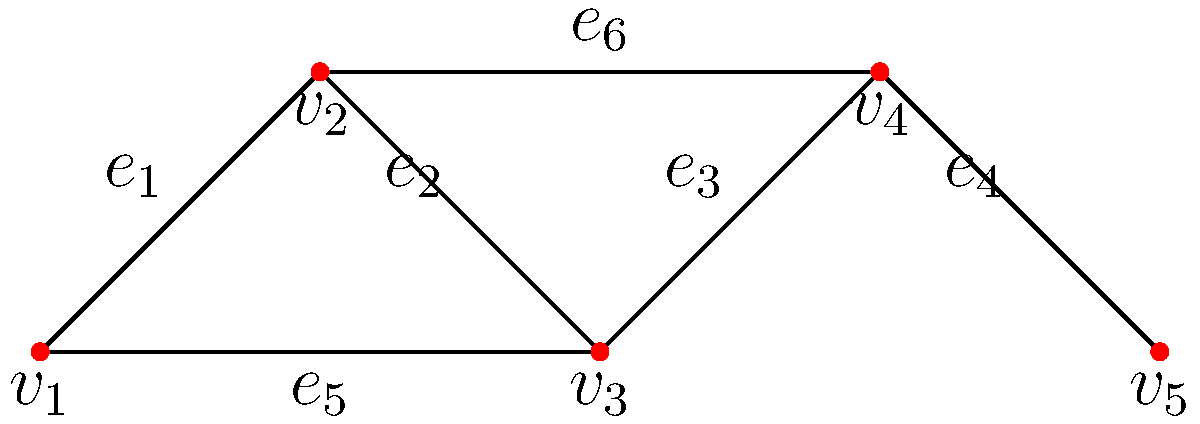As a city council member, you're reviewing a proposal to improve the connectivity of your city's road network. The current network is represented by the graph above, where vertices represent intersections and edges represent roads. What is the minimum number of additional roads (edges) that need to be constructed to make this graph 2-edge-connected, ensuring that the removal of any single road won't disconnect the network? To solve this problem, we need to understand the concept of 2-edge-connectivity and analyze the given graph:

1. A graph is 2-edge-connected if it remains connected after removing any single edge.

2. Examine the current graph:
   - It has 5 vertices ($v_1$ to $v_5$) and 6 edges ($e_1$ to $e_6$).
   - The graph is connected, but not 2-edge-connected.

3. Identify critical edges:
   - $e_4$ is a critical edge. If removed, it disconnects $v_5$ from the rest of the graph.
   - $e_5$ and $e_6$ are not critical, as their removal doesn't disconnect the graph.

4. To make the graph 2-edge-connected:
   - We need to add one edge to create an alternative path to $v_5$.
   - The most efficient option is to add an edge between $v_5$ and any other vertex except $v_4$.

5. Possible solutions:
   - Add an edge between $v_5$ and $v_1$, $v_2$, or $v_3$.
   - Any of these additions will make the graph 2-edge-connected.

6. Minimum number of edges to add:
   - Only one edge needs to be added to achieve 2-edge-connectivity.

Therefore, the minimum number of additional roads (edges) needed to make this graph 2-edge-connected is 1.
Answer: 1 